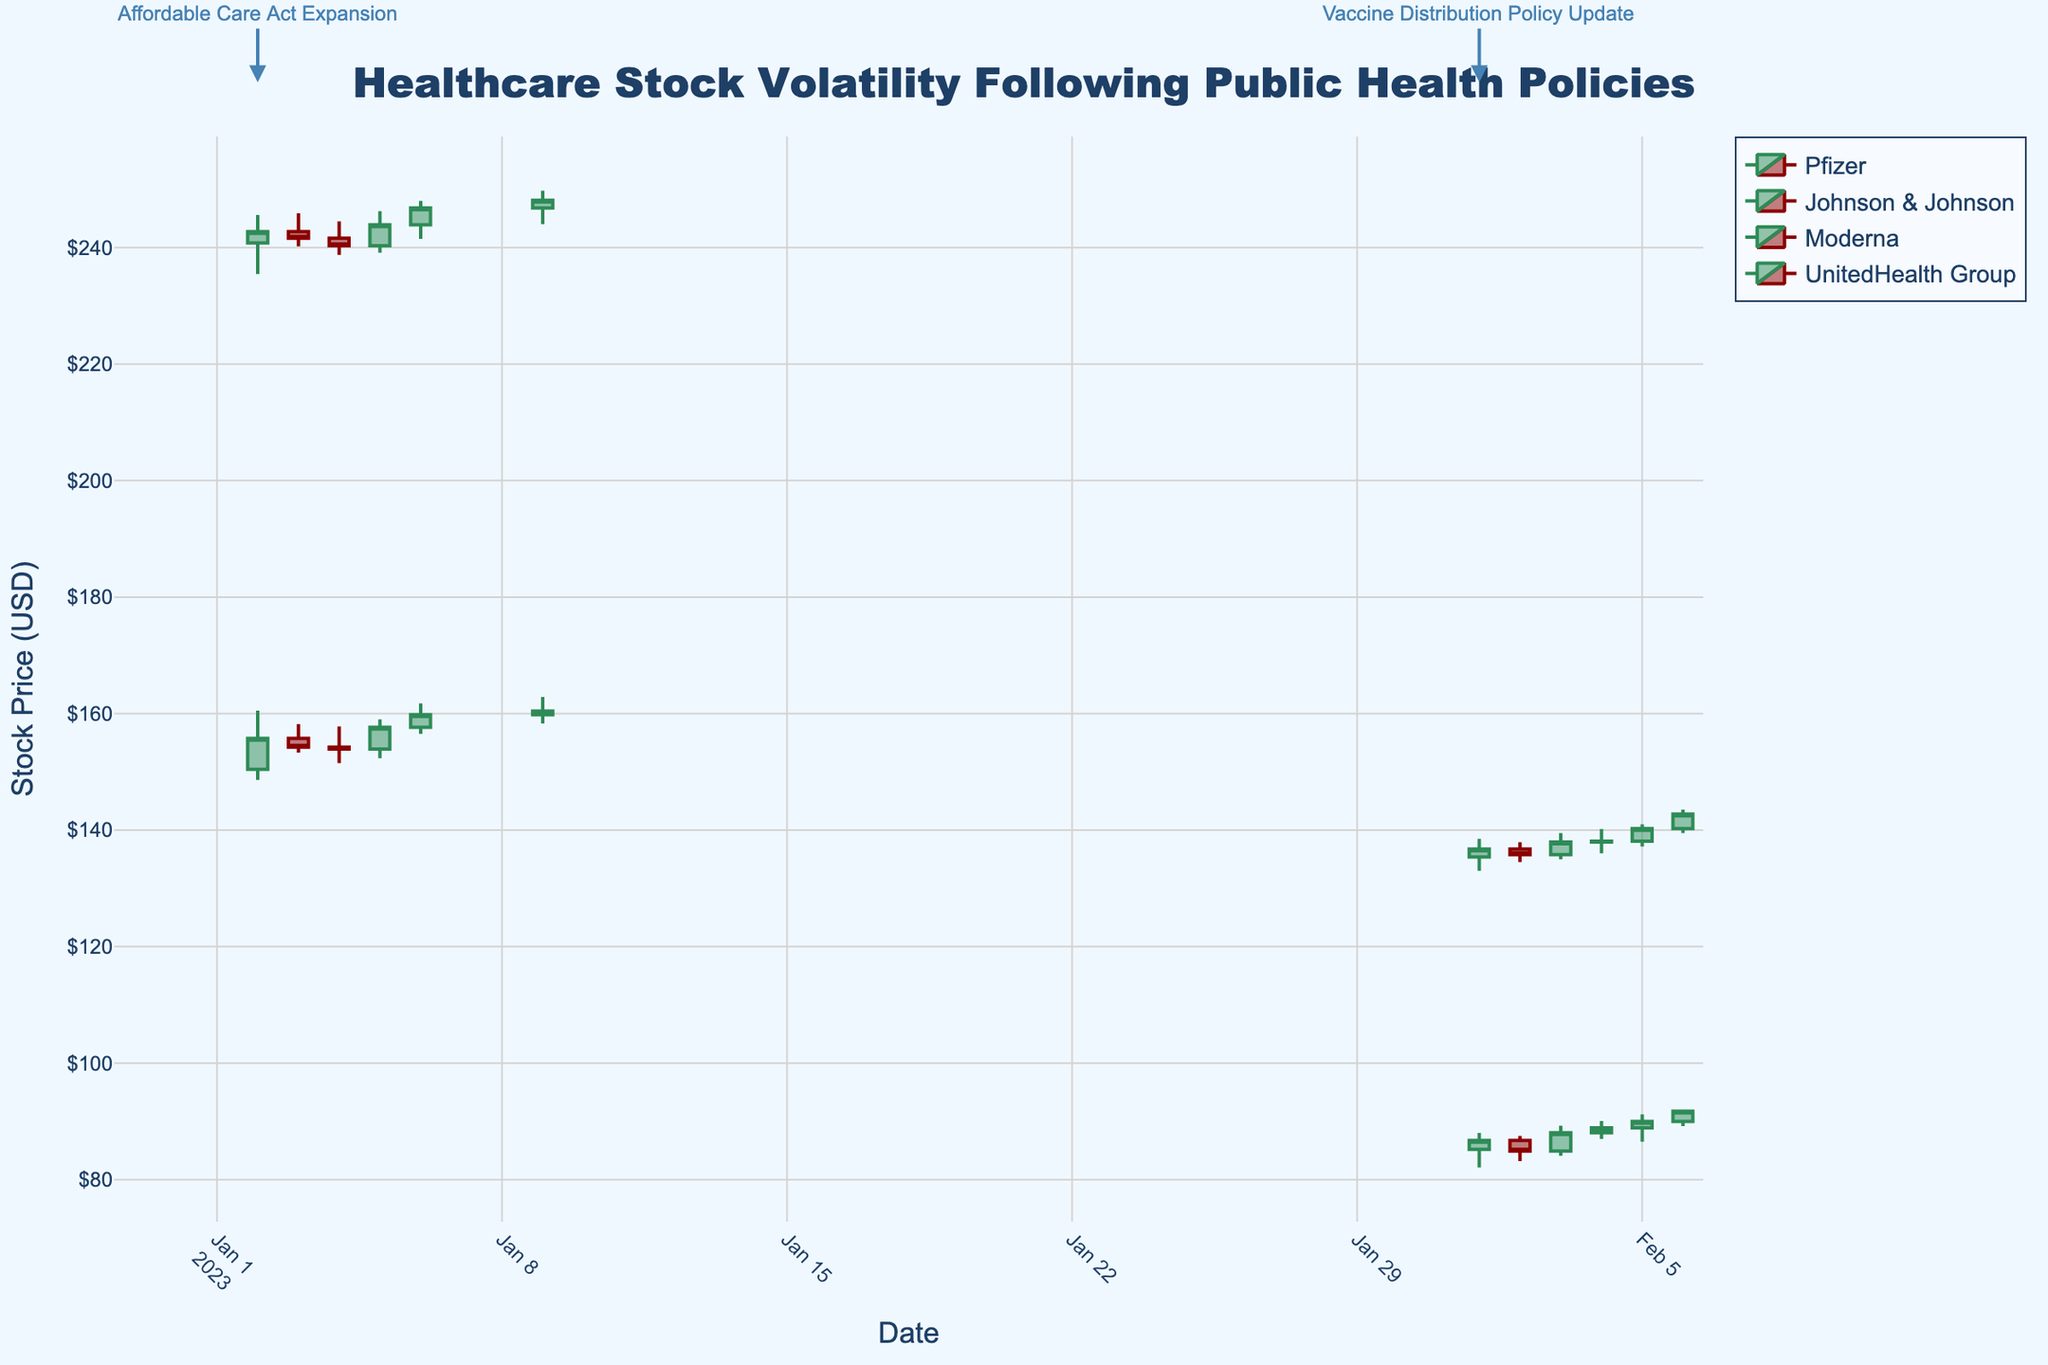What is the title of the figure? The title is located at the top center of the figure, it reads "Healthcare Stock Volatility Following Public Health Policies."
Answer: Healthcare Stock Volatility Following Public Health Policies Which company has the highest stock price on January 9, 2023? By checking the candles for January 9, we can compare the closing prices for each company. The highest candle is from Johnson & Johnson with a closing price of $248.10.
Answer: Johnson & Johnson How did Pfizer's stock price move from January 2, 2023, to January 6, 2023? Observing the candlestick patterns for Pfizer from January 2 to January 6, 2023, the stock opened at $150.45 and closed at $159.80, showing an overall upward trend over the period.
Answer: Upward Compare the stock price volatility of Moderna and UnitedHealth Group from February 1, 2023, to February 6, 2023. Who had higher volatility? Volatility can be assessed by examining the range between the high and low prices for each company. Moderna's prices ranged from $82.10 to $92, while UnitedHealth Group's prices ranged from $133 to $143.50. The larger range in prices indicates higher volatility for Moderna.
Answer: Moderna What stock had the most significant increase in its closing price in a single day? By comparing the changes in closing prices day-by-day for each company, Pfizer's closing price from January 5 to January 6 increased from $157.65 to $159.80, which is the largest single-day increase.
Answer: Pfizer On which date was the "Vaccine Distribution Policy Update" policy introduced, and which companies reacted? The policy annotations in the figure show the "Vaccine Distribution Policy Update" was introduced on February 1, 2023. Companies affected by this policy are Moderna and UnitedHealth Group, judging by the change in patterns from that date on their candles.
Answer: February 1, 2023, Moderna, UnitedHealth Group Which company has the highest volume of shares traded on February 3, 2023? Checking the volume data for February 3, 2023, Moderna has the highest volume of shares traded at 4.6 million.
Answer: Moderna How did the introduction of the "Affordable Care Act Expansion" impact Pfizer's stock price in the first week? By examining Pfizer’s candlestick patterns from January 2 to January 6 after the policy was introduced, the opening price was $150.45, and the closing price on January 6 was $159.80, showing a positive effect with increasing prices.
Answer: Increased Which stock displayed the most consistent upward trend through January? Johnson & Johnson exhibited a consistent upward trend, where each day from January 2 to January 9 showed increasing or stable closing prices.
Answer: Johnson & Johnson 